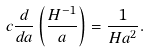<formula> <loc_0><loc_0><loc_500><loc_500>c \frac { d } { d a } \left ( \frac { H ^ { - 1 } } { a } \right ) = \frac { 1 } { H a ^ { 2 } } .</formula> 